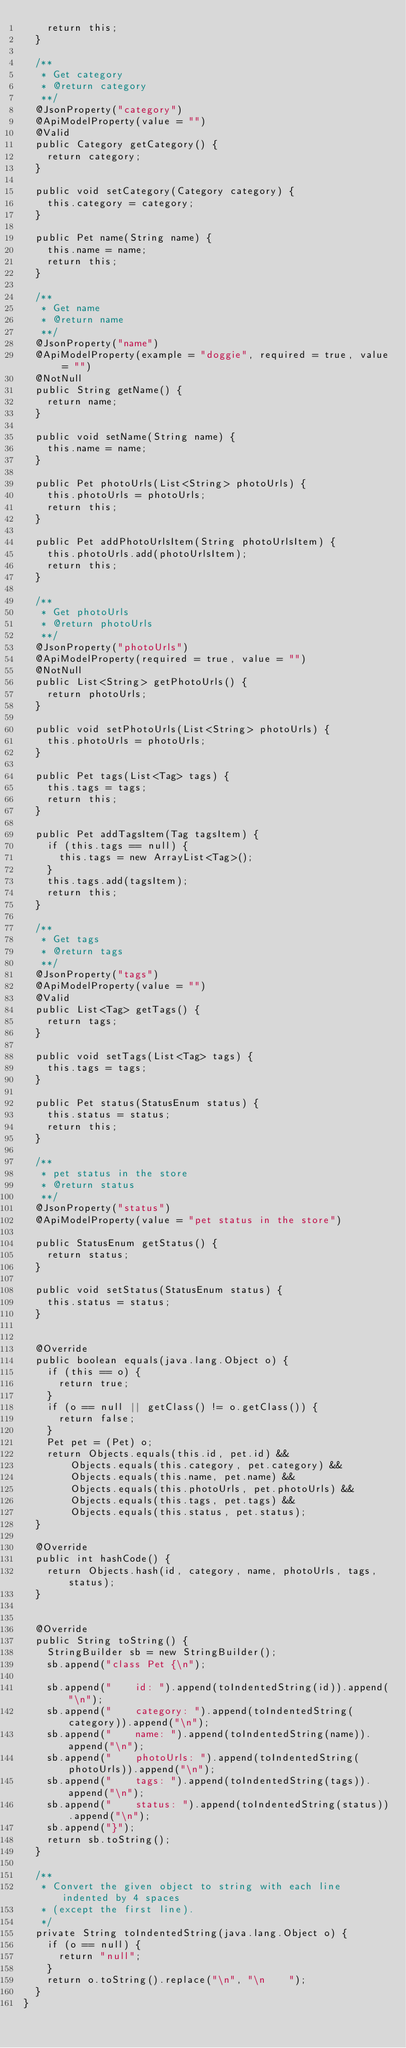<code> <loc_0><loc_0><loc_500><loc_500><_Java_>    return this;
  }

  /**
   * Get category
   * @return category
   **/
  @JsonProperty("category")
  @ApiModelProperty(value = "")
  @Valid 
  public Category getCategory() {
    return category;
  }

  public void setCategory(Category category) {
    this.category = category;
  }

  public Pet name(String name) {
    this.name = name;
    return this;
  }

  /**
   * Get name
   * @return name
   **/
  @JsonProperty("name")
  @ApiModelProperty(example = "doggie", required = true, value = "")
  @NotNull 
  public String getName() {
    return name;
  }

  public void setName(String name) {
    this.name = name;
  }

  public Pet photoUrls(List<String> photoUrls) {
    this.photoUrls = photoUrls;
    return this;
  }

  public Pet addPhotoUrlsItem(String photoUrlsItem) {
    this.photoUrls.add(photoUrlsItem);
    return this;
  }

  /**
   * Get photoUrls
   * @return photoUrls
   **/
  @JsonProperty("photoUrls")
  @ApiModelProperty(required = true, value = "")
  @NotNull 
  public List<String> getPhotoUrls() {
    return photoUrls;
  }

  public void setPhotoUrls(List<String> photoUrls) {
    this.photoUrls = photoUrls;
  }

  public Pet tags(List<Tag> tags) {
    this.tags = tags;
    return this;
  }

  public Pet addTagsItem(Tag tagsItem) {
    if (this.tags == null) {
      this.tags = new ArrayList<Tag>();
    }
    this.tags.add(tagsItem);
    return this;
  }

  /**
   * Get tags
   * @return tags
   **/
  @JsonProperty("tags")
  @ApiModelProperty(value = "")
  @Valid 
  public List<Tag> getTags() {
    return tags;
  }

  public void setTags(List<Tag> tags) {
    this.tags = tags;
  }

  public Pet status(StatusEnum status) {
    this.status = status;
    return this;
  }

  /**
   * pet status in the store
   * @return status
   **/
  @JsonProperty("status")
  @ApiModelProperty(value = "pet status in the store")
  
  public StatusEnum getStatus() {
    return status;
  }

  public void setStatus(StatusEnum status) {
    this.status = status;
  }


  @Override
  public boolean equals(java.lang.Object o) {
    if (this == o) {
      return true;
    }
    if (o == null || getClass() != o.getClass()) {
      return false;
    }
    Pet pet = (Pet) o;
    return Objects.equals(this.id, pet.id) &&
        Objects.equals(this.category, pet.category) &&
        Objects.equals(this.name, pet.name) &&
        Objects.equals(this.photoUrls, pet.photoUrls) &&
        Objects.equals(this.tags, pet.tags) &&
        Objects.equals(this.status, pet.status);
  }

  @Override
  public int hashCode() {
    return Objects.hash(id, category, name, photoUrls, tags, status);
  }


  @Override
  public String toString() {
    StringBuilder sb = new StringBuilder();
    sb.append("class Pet {\n");
    
    sb.append("    id: ").append(toIndentedString(id)).append("\n");
    sb.append("    category: ").append(toIndentedString(category)).append("\n");
    sb.append("    name: ").append(toIndentedString(name)).append("\n");
    sb.append("    photoUrls: ").append(toIndentedString(photoUrls)).append("\n");
    sb.append("    tags: ").append(toIndentedString(tags)).append("\n");
    sb.append("    status: ").append(toIndentedString(status)).append("\n");
    sb.append("}");
    return sb.toString();
  }

  /**
   * Convert the given object to string with each line indented by 4 spaces
   * (except the first line).
   */
  private String toIndentedString(java.lang.Object o) {
    if (o == null) {
      return "null";
    }
    return o.toString().replace("\n", "\n    ");
  }
}

</code> 